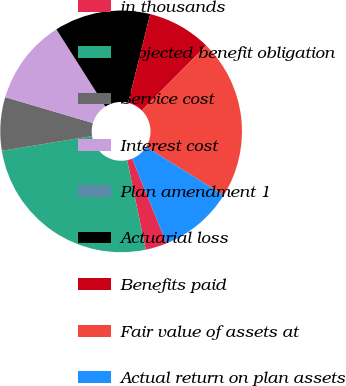<chart> <loc_0><loc_0><loc_500><loc_500><pie_chart><fcel>in thousands<fcel>Projected benefit obligation<fcel>Service cost<fcel>Interest cost<fcel>Plan amendment 1<fcel>Actuarial loss<fcel>Benefits paid<fcel>Fair value of assets at<fcel>Actual return on plan assets<nl><fcel>2.86%<fcel>25.71%<fcel>7.14%<fcel>11.43%<fcel>0.0%<fcel>12.86%<fcel>8.57%<fcel>21.43%<fcel>10.0%<nl></chart> 